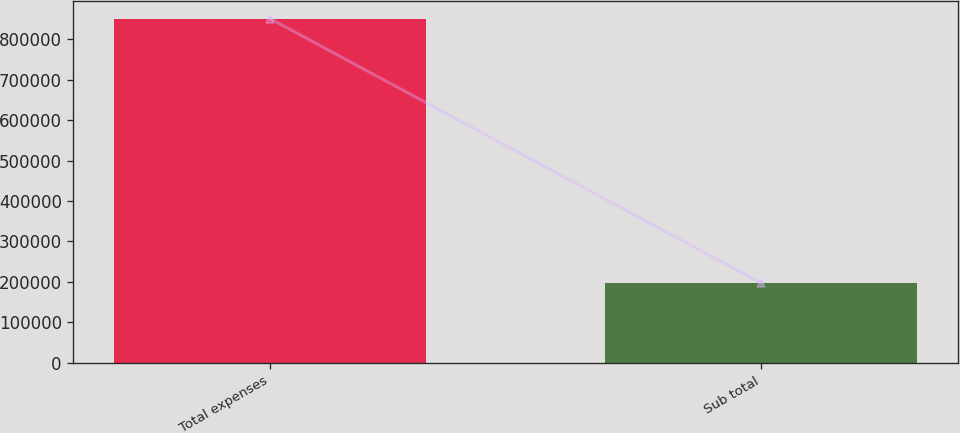Convert chart. <chart><loc_0><loc_0><loc_500><loc_500><bar_chart><fcel>Total expenses<fcel>Sub total<nl><fcel>850442<fcel>197341<nl></chart> 